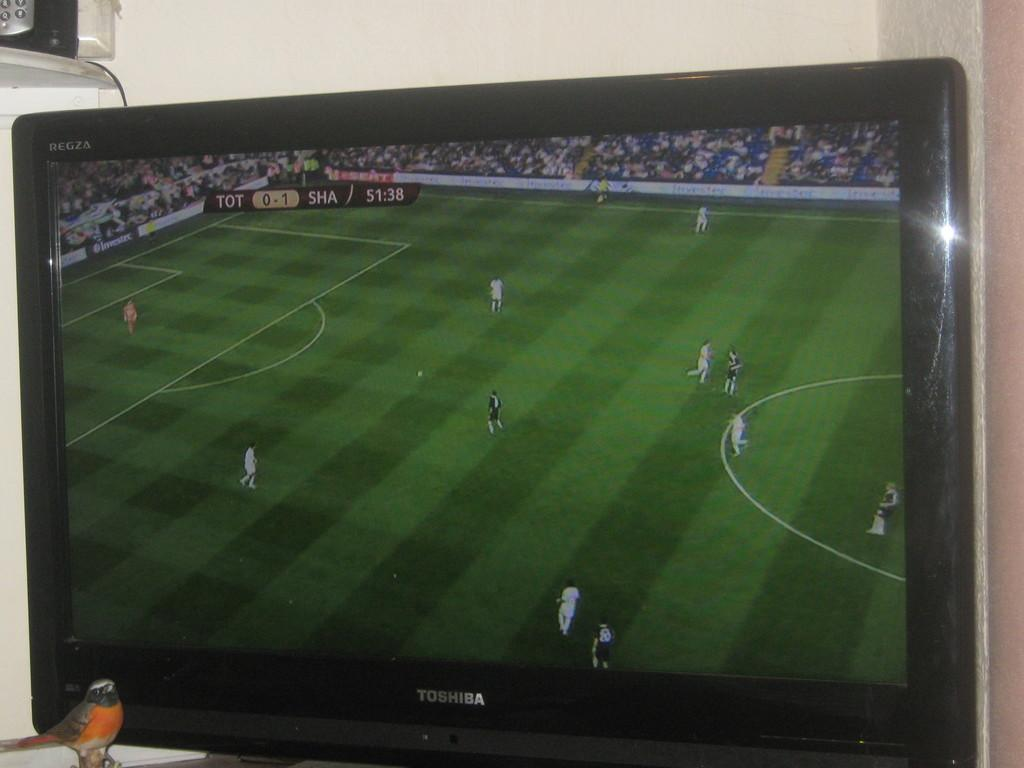<image>
Summarize the visual content of the image. A Toshiba brand TV displays a soccer game between TOT and SHA. 